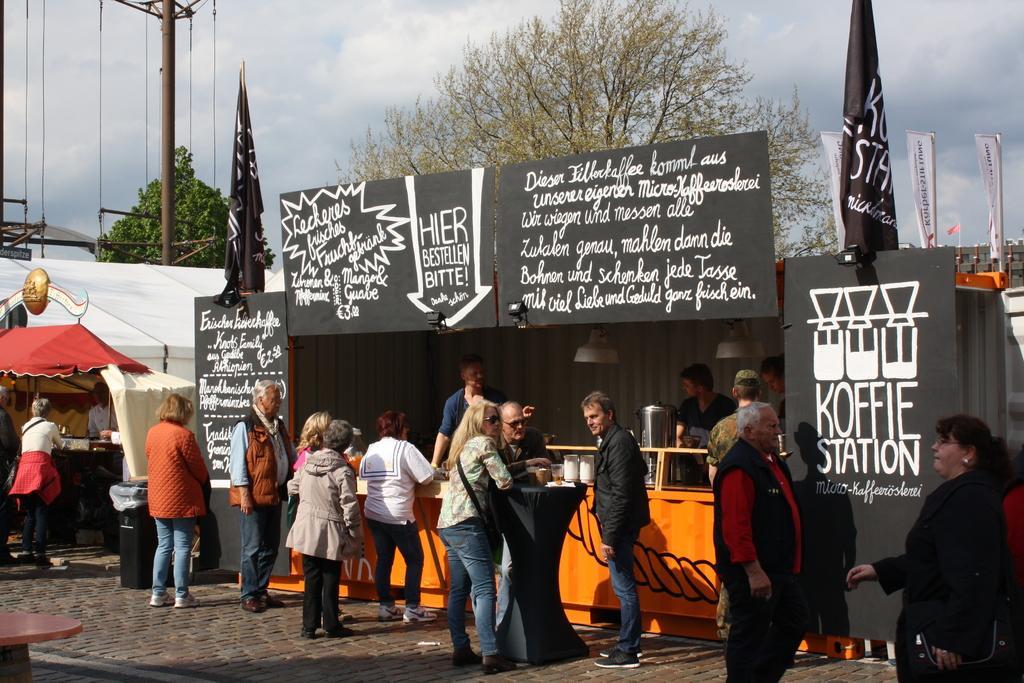In one or two sentences, can you explain what this image depicts? In this image I can see number of people are standing. I can also see most of them are wearing jackets and few of them are wearing shades. In the background I can see few stalls, boards, flags, trees, clouds, the sky, a pole, few wires and here on these boards I can see something is written. 